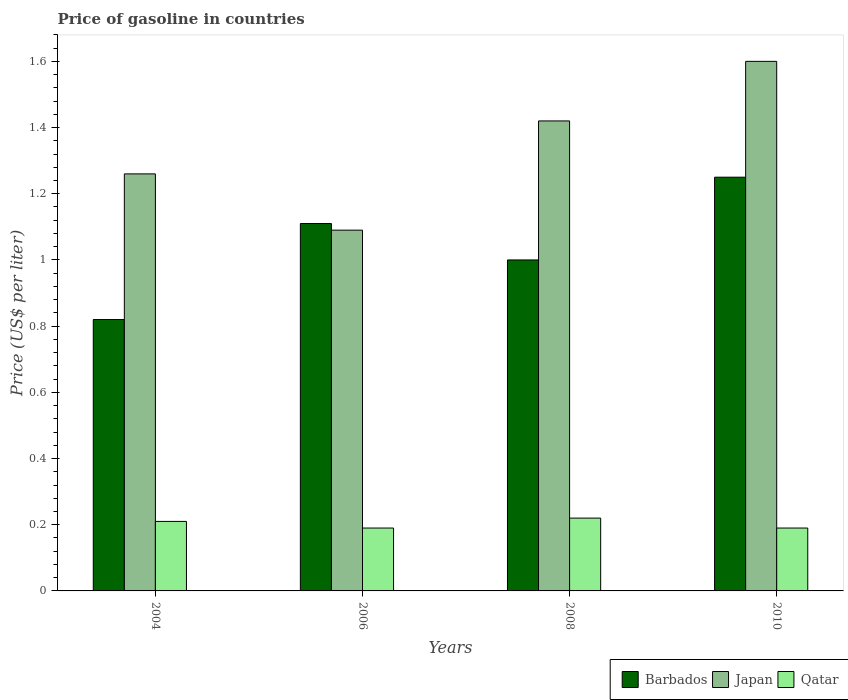Are the number of bars per tick equal to the number of legend labels?
Make the answer very short. Yes. Are the number of bars on each tick of the X-axis equal?
Ensure brevity in your answer.  Yes. How many bars are there on the 2nd tick from the left?
Make the answer very short. 3. How many bars are there on the 1st tick from the right?
Your answer should be compact. 3. In how many cases, is the number of bars for a given year not equal to the number of legend labels?
Give a very brief answer. 0. What is the price of gasoline in Japan in 2004?
Your response must be concise. 1.26. Across all years, what is the minimum price of gasoline in Japan?
Make the answer very short. 1.09. In which year was the price of gasoline in Qatar minimum?
Make the answer very short. 2006. What is the total price of gasoline in Barbados in the graph?
Your answer should be very brief. 4.18. What is the difference between the price of gasoline in Barbados in 2004 and that in 2010?
Keep it short and to the point. -0.43. What is the difference between the price of gasoline in Japan in 2008 and the price of gasoline in Barbados in 2006?
Offer a very short reply. 0.31. What is the average price of gasoline in Barbados per year?
Provide a succinct answer. 1.04. In the year 2006, what is the difference between the price of gasoline in Japan and price of gasoline in Barbados?
Offer a very short reply. -0.02. What is the ratio of the price of gasoline in Qatar in 2004 to that in 2006?
Your response must be concise. 1.11. Is the price of gasoline in Japan in 2004 less than that in 2008?
Your answer should be compact. Yes. Is the difference between the price of gasoline in Japan in 2004 and 2010 greater than the difference between the price of gasoline in Barbados in 2004 and 2010?
Your answer should be compact. Yes. What is the difference between the highest and the second highest price of gasoline in Barbados?
Offer a very short reply. 0.14. In how many years, is the price of gasoline in Barbados greater than the average price of gasoline in Barbados taken over all years?
Offer a very short reply. 2. Is the sum of the price of gasoline in Qatar in 2004 and 2010 greater than the maximum price of gasoline in Barbados across all years?
Your answer should be compact. No. What does the 3rd bar from the left in 2006 represents?
Provide a succinct answer. Qatar. What does the 1st bar from the right in 2010 represents?
Offer a terse response. Qatar. Is it the case that in every year, the sum of the price of gasoline in Japan and price of gasoline in Barbados is greater than the price of gasoline in Qatar?
Your answer should be very brief. Yes. How many bars are there?
Give a very brief answer. 12. How many years are there in the graph?
Ensure brevity in your answer.  4. Does the graph contain any zero values?
Offer a very short reply. No. Does the graph contain grids?
Your answer should be compact. No. How are the legend labels stacked?
Give a very brief answer. Horizontal. What is the title of the graph?
Offer a terse response. Price of gasoline in countries. Does "Ukraine" appear as one of the legend labels in the graph?
Give a very brief answer. No. What is the label or title of the Y-axis?
Offer a very short reply. Price (US$ per liter). What is the Price (US$ per liter) in Barbados in 2004?
Your answer should be very brief. 0.82. What is the Price (US$ per liter) in Japan in 2004?
Give a very brief answer. 1.26. What is the Price (US$ per liter) of Qatar in 2004?
Your response must be concise. 0.21. What is the Price (US$ per liter) of Barbados in 2006?
Provide a succinct answer. 1.11. What is the Price (US$ per liter) in Japan in 2006?
Offer a terse response. 1.09. What is the Price (US$ per liter) of Qatar in 2006?
Your answer should be very brief. 0.19. What is the Price (US$ per liter) of Japan in 2008?
Your answer should be very brief. 1.42. What is the Price (US$ per liter) in Qatar in 2008?
Offer a very short reply. 0.22. What is the Price (US$ per liter) in Barbados in 2010?
Make the answer very short. 1.25. What is the Price (US$ per liter) of Qatar in 2010?
Your answer should be very brief. 0.19. Across all years, what is the maximum Price (US$ per liter) of Japan?
Keep it short and to the point. 1.6. Across all years, what is the maximum Price (US$ per liter) in Qatar?
Provide a short and direct response. 0.22. Across all years, what is the minimum Price (US$ per liter) in Barbados?
Provide a short and direct response. 0.82. Across all years, what is the minimum Price (US$ per liter) in Japan?
Make the answer very short. 1.09. Across all years, what is the minimum Price (US$ per liter) in Qatar?
Provide a succinct answer. 0.19. What is the total Price (US$ per liter) of Barbados in the graph?
Your answer should be compact. 4.18. What is the total Price (US$ per liter) in Japan in the graph?
Your response must be concise. 5.37. What is the total Price (US$ per liter) of Qatar in the graph?
Offer a terse response. 0.81. What is the difference between the Price (US$ per liter) of Barbados in 2004 and that in 2006?
Keep it short and to the point. -0.29. What is the difference between the Price (US$ per liter) of Japan in 2004 and that in 2006?
Keep it short and to the point. 0.17. What is the difference between the Price (US$ per liter) in Qatar in 2004 and that in 2006?
Your answer should be compact. 0.02. What is the difference between the Price (US$ per liter) of Barbados in 2004 and that in 2008?
Keep it short and to the point. -0.18. What is the difference between the Price (US$ per liter) of Japan in 2004 and that in 2008?
Offer a very short reply. -0.16. What is the difference between the Price (US$ per liter) in Qatar in 2004 and that in 2008?
Provide a short and direct response. -0.01. What is the difference between the Price (US$ per liter) in Barbados in 2004 and that in 2010?
Keep it short and to the point. -0.43. What is the difference between the Price (US$ per liter) in Japan in 2004 and that in 2010?
Your answer should be compact. -0.34. What is the difference between the Price (US$ per liter) of Qatar in 2004 and that in 2010?
Ensure brevity in your answer.  0.02. What is the difference between the Price (US$ per liter) of Barbados in 2006 and that in 2008?
Your response must be concise. 0.11. What is the difference between the Price (US$ per liter) in Japan in 2006 and that in 2008?
Your answer should be very brief. -0.33. What is the difference between the Price (US$ per liter) of Qatar in 2006 and that in 2008?
Offer a very short reply. -0.03. What is the difference between the Price (US$ per liter) of Barbados in 2006 and that in 2010?
Keep it short and to the point. -0.14. What is the difference between the Price (US$ per liter) in Japan in 2006 and that in 2010?
Offer a terse response. -0.51. What is the difference between the Price (US$ per liter) of Japan in 2008 and that in 2010?
Your answer should be compact. -0.18. What is the difference between the Price (US$ per liter) in Qatar in 2008 and that in 2010?
Offer a terse response. 0.03. What is the difference between the Price (US$ per liter) of Barbados in 2004 and the Price (US$ per liter) of Japan in 2006?
Give a very brief answer. -0.27. What is the difference between the Price (US$ per liter) in Barbados in 2004 and the Price (US$ per liter) in Qatar in 2006?
Your answer should be compact. 0.63. What is the difference between the Price (US$ per liter) of Japan in 2004 and the Price (US$ per liter) of Qatar in 2006?
Give a very brief answer. 1.07. What is the difference between the Price (US$ per liter) in Barbados in 2004 and the Price (US$ per liter) in Qatar in 2008?
Offer a very short reply. 0.6. What is the difference between the Price (US$ per liter) in Barbados in 2004 and the Price (US$ per liter) in Japan in 2010?
Offer a terse response. -0.78. What is the difference between the Price (US$ per liter) of Barbados in 2004 and the Price (US$ per liter) of Qatar in 2010?
Your answer should be very brief. 0.63. What is the difference between the Price (US$ per liter) in Japan in 2004 and the Price (US$ per liter) in Qatar in 2010?
Make the answer very short. 1.07. What is the difference between the Price (US$ per liter) of Barbados in 2006 and the Price (US$ per liter) of Japan in 2008?
Your answer should be compact. -0.31. What is the difference between the Price (US$ per liter) in Barbados in 2006 and the Price (US$ per liter) in Qatar in 2008?
Provide a succinct answer. 0.89. What is the difference between the Price (US$ per liter) in Japan in 2006 and the Price (US$ per liter) in Qatar in 2008?
Provide a short and direct response. 0.87. What is the difference between the Price (US$ per liter) of Barbados in 2006 and the Price (US$ per liter) of Japan in 2010?
Your answer should be compact. -0.49. What is the difference between the Price (US$ per liter) of Barbados in 2006 and the Price (US$ per liter) of Qatar in 2010?
Your response must be concise. 0.92. What is the difference between the Price (US$ per liter) of Barbados in 2008 and the Price (US$ per liter) of Japan in 2010?
Offer a very short reply. -0.6. What is the difference between the Price (US$ per liter) of Barbados in 2008 and the Price (US$ per liter) of Qatar in 2010?
Provide a short and direct response. 0.81. What is the difference between the Price (US$ per liter) in Japan in 2008 and the Price (US$ per liter) in Qatar in 2010?
Offer a very short reply. 1.23. What is the average Price (US$ per liter) of Barbados per year?
Offer a terse response. 1.04. What is the average Price (US$ per liter) in Japan per year?
Your response must be concise. 1.34. What is the average Price (US$ per liter) in Qatar per year?
Ensure brevity in your answer.  0.2. In the year 2004, what is the difference between the Price (US$ per liter) in Barbados and Price (US$ per liter) in Japan?
Ensure brevity in your answer.  -0.44. In the year 2004, what is the difference between the Price (US$ per liter) in Barbados and Price (US$ per liter) in Qatar?
Your answer should be very brief. 0.61. In the year 2004, what is the difference between the Price (US$ per liter) in Japan and Price (US$ per liter) in Qatar?
Offer a very short reply. 1.05. In the year 2006, what is the difference between the Price (US$ per liter) in Barbados and Price (US$ per liter) in Japan?
Offer a terse response. 0.02. In the year 2006, what is the difference between the Price (US$ per liter) in Barbados and Price (US$ per liter) in Qatar?
Offer a very short reply. 0.92. In the year 2006, what is the difference between the Price (US$ per liter) in Japan and Price (US$ per liter) in Qatar?
Your response must be concise. 0.9. In the year 2008, what is the difference between the Price (US$ per liter) in Barbados and Price (US$ per liter) in Japan?
Your answer should be very brief. -0.42. In the year 2008, what is the difference between the Price (US$ per liter) of Barbados and Price (US$ per liter) of Qatar?
Provide a succinct answer. 0.78. In the year 2008, what is the difference between the Price (US$ per liter) of Japan and Price (US$ per liter) of Qatar?
Your answer should be compact. 1.2. In the year 2010, what is the difference between the Price (US$ per liter) of Barbados and Price (US$ per liter) of Japan?
Give a very brief answer. -0.35. In the year 2010, what is the difference between the Price (US$ per liter) of Barbados and Price (US$ per liter) of Qatar?
Your response must be concise. 1.06. In the year 2010, what is the difference between the Price (US$ per liter) of Japan and Price (US$ per liter) of Qatar?
Provide a succinct answer. 1.41. What is the ratio of the Price (US$ per liter) in Barbados in 2004 to that in 2006?
Your answer should be very brief. 0.74. What is the ratio of the Price (US$ per liter) of Japan in 2004 to that in 2006?
Provide a short and direct response. 1.16. What is the ratio of the Price (US$ per liter) in Qatar in 2004 to that in 2006?
Make the answer very short. 1.11. What is the ratio of the Price (US$ per liter) in Barbados in 2004 to that in 2008?
Give a very brief answer. 0.82. What is the ratio of the Price (US$ per liter) of Japan in 2004 to that in 2008?
Keep it short and to the point. 0.89. What is the ratio of the Price (US$ per liter) in Qatar in 2004 to that in 2008?
Provide a short and direct response. 0.95. What is the ratio of the Price (US$ per liter) of Barbados in 2004 to that in 2010?
Offer a terse response. 0.66. What is the ratio of the Price (US$ per liter) in Japan in 2004 to that in 2010?
Offer a terse response. 0.79. What is the ratio of the Price (US$ per liter) in Qatar in 2004 to that in 2010?
Ensure brevity in your answer.  1.11. What is the ratio of the Price (US$ per liter) of Barbados in 2006 to that in 2008?
Make the answer very short. 1.11. What is the ratio of the Price (US$ per liter) in Japan in 2006 to that in 2008?
Provide a short and direct response. 0.77. What is the ratio of the Price (US$ per liter) of Qatar in 2006 to that in 2008?
Provide a short and direct response. 0.86. What is the ratio of the Price (US$ per liter) in Barbados in 2006 to that in 2010?
Ensure brevity in your answer.  0.89. What is the ratio of the Price (US$ per liter) in Japan in 2006 to that in 2010?
Provide a succinct answer. 0.68. What is the ratio of the Price (US$ per liter) of Qatar in 2006 to that in 2010?
Offer a terse response. 1. What is the ratio of the Price (US$ per liter) of Barbados in 2008 to that in 2010?
Give a very brief answer. 0.8. What is the ratio of the Price (US$ per liter) of Japan in 2008 to that in 2010?
Give a very brief answer. 0.89. What is the ratio of the Price (US$ per liter) of Qatar in 2008 to that in 2010?
Provide a short and direct response. 1.16. What is the difference between the highest and the second highest Price (US$ per liter) in Barbados?
Your response must be concise. 0.14. What is the difference between the highest and the second highest Price (US$ per liter) of Japan?
Offer a very short reply. 0.18. What is the difference between the highest and the lowest Price (US$ per liter) of Barbados?
Offer a very short reply. 0.43. What is the difference between the highest and the lowest Price (US$ per liter) of Japan?
Give a very brief answer. 0.51. What is the difference between the highest and the lowest Price (US$ per liter) in Qatar?
Give a very brief answer. 0.03. 